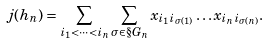Convert formula to latex. <formula><loc_0><loc_0><loc_500><loc_500>j ( h _ { n } ) = \sum _ { i _ { 1 } < \cdots < i _ { n } } \sum _ { \sigma \in \S G _ { n } } x _ { i _ { 1 } i _ { \sigma ( 1 ) } } \dots x _ { i _ { n } i _ { \sigma ( n ) } } .</formula> 